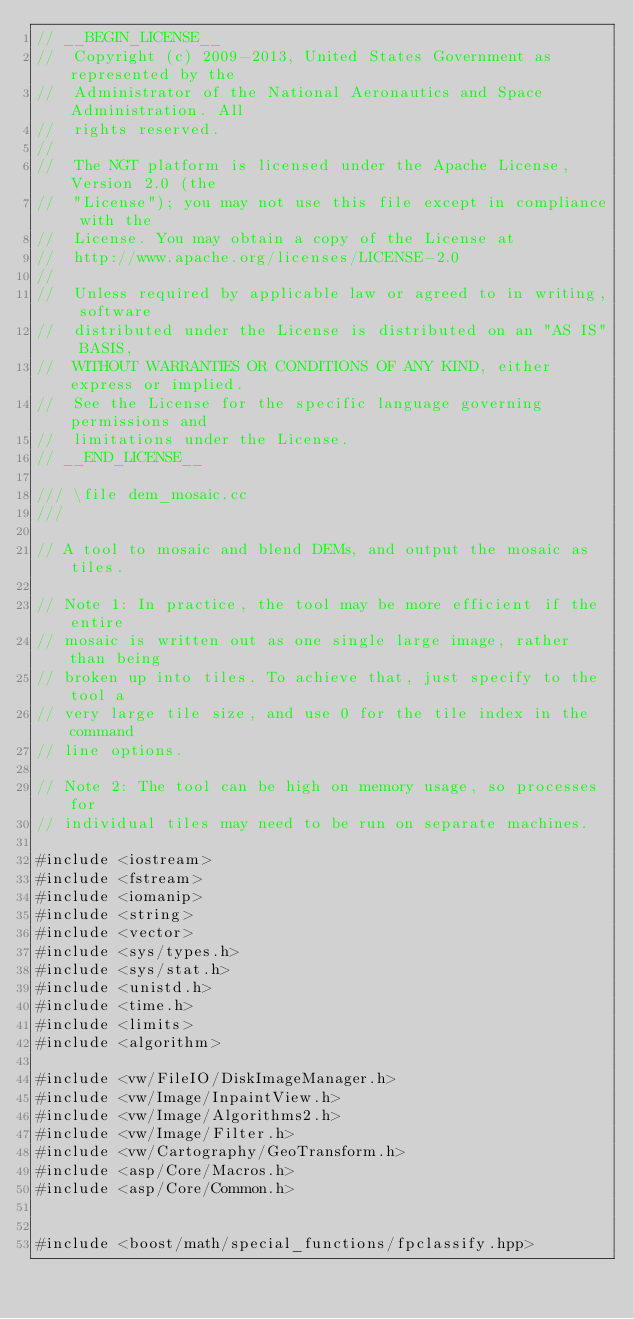Convert code to text. <code><loc_0><loc_0><loc_500><loc_500><_C++_>// __BEGIN_LICENSE__
//  Copyright (c) 2009-2013, United States Government as represented by the
//  Administrator of the National Aeronautics and Space Administration. All
//  rights reserved.
//
//  The NGT platform is licensed under the Apache License, Version 2.0 (the
//  "License"); you may not use this file except in compliance with the
//  License. You may obtain a copy of the License at
//  http://www.apache.org/licenses/LICENSE-2.0
//
//  Unless required by applicable law or agreed to in writing, software
//  distributed under the License is distributed on an "AS IS" BASIS,
//  WITHOUT WARRANTIES OR CONDITIONS OF ANY KIND, either express or implied.
//  See the License for the specific language governing permissions and
//  limitations under the License.
// __END_LICENSE__

/// \file dem_mosaic.cc
///

// A tool to mosaic and blend DEMs, and output the mosaic as tiles.

// Note 1: In practice, the tool may be more efficient if the entire
// mosaic is written out as one single large image, rather than being
// broken up into tiles. To achieve that, just specify to the tool a
// very large tile size, and use 0 for the tile index in the command
// line options.

// Note 2: The tool can be high on memory usage, so processes for
// individual tiles may need to be run on separate machines.

#include <iostream>
#include <fstream>
#include <iomanip>
#include <string>
#include <vector>
#include <sys/types.h>
#include <sys/stat.h>
#include <unistd.h>
#include <time.h>
#include <limits>
#include <algorithm>

#include <vw/FileIO/DiskImageManager.h>
#include <vw/Image/InpaintView.h>
#include <vw/Image/Algorithms2.h>
#include <vw/Image/Filter.h>
#include <vw/Cartography/GeoTransform.h>
#include <asp/Core/Macros.h>
#include <asp/Core/Common.h>


#include <boost/math/special_functions/fpclassify.hpp></code> 